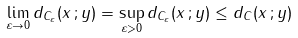<formula> <loc_0><loc_0><loc_500><loc_500>\lim _ { \varepsilon \to 0 } d _ { C _ { \varepsilon } } ( x \, ; y ) = \sup _ { \varepsilon > 0 } d _ { C _ { \varepsilon } } ( x \, ; y ) \leq d _ { C } ( x \, ; y )</formula> 